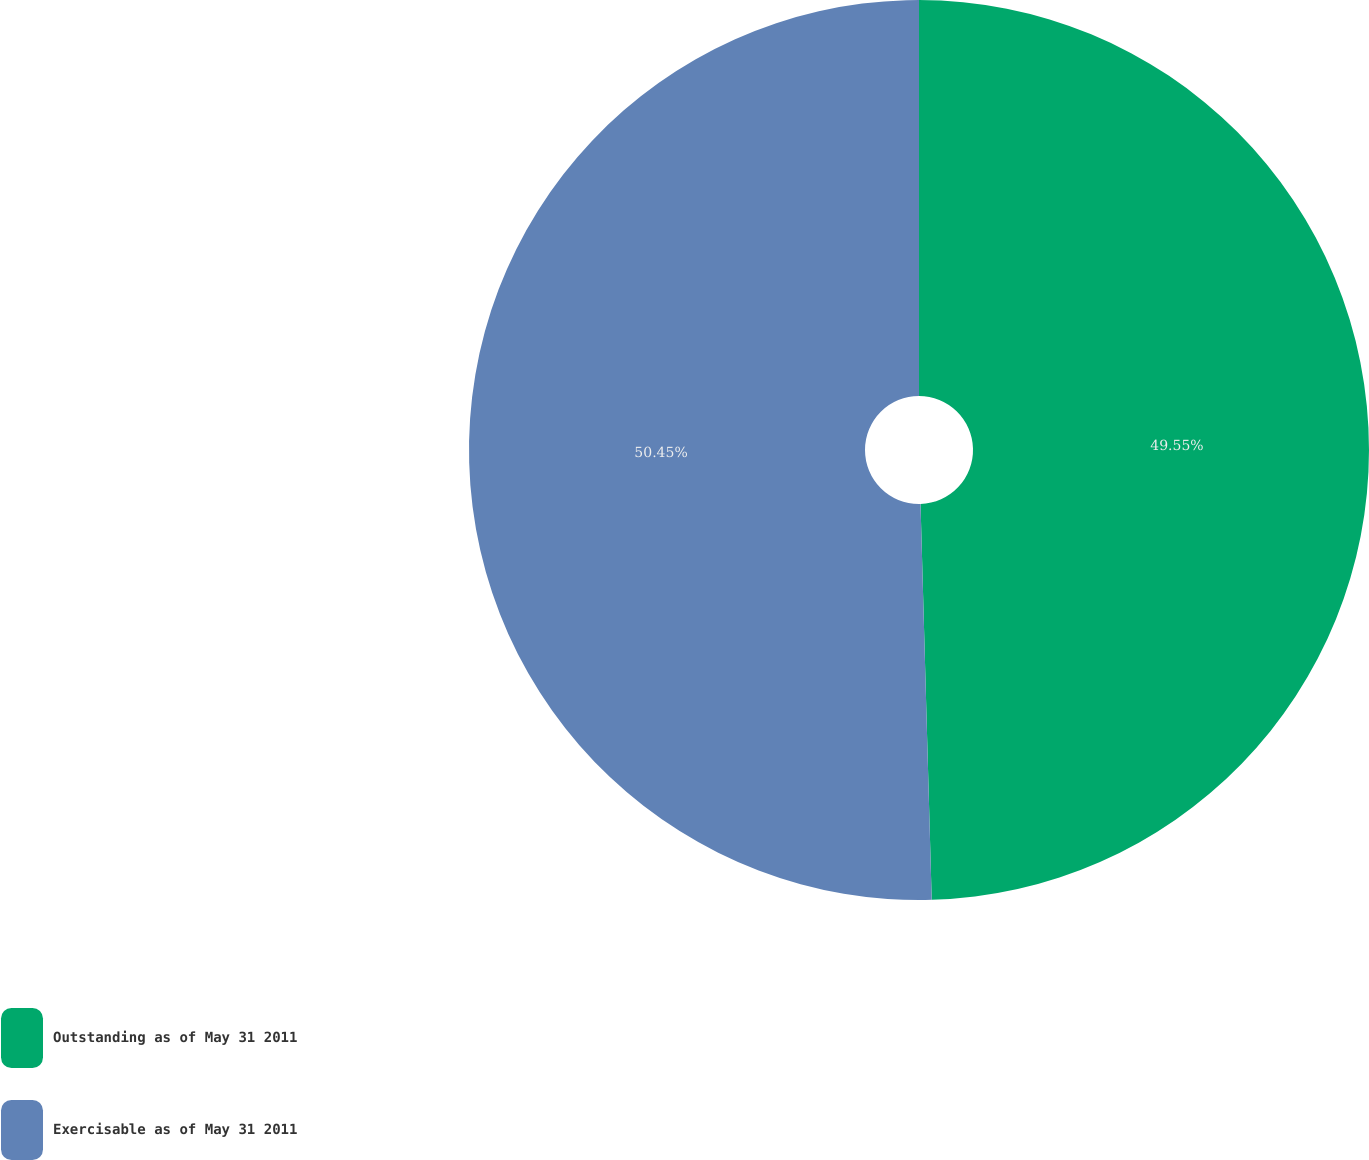Convert chart to OTSL. <chart><loc_0><loc_0><loc_500><loc_500><pie_chart><fcel>Outstanding as of May 31 2011<fcel>Exercisable as of May 31 2011<nl><fcel>49.55%<fcel>50.45%<nl></chart> 